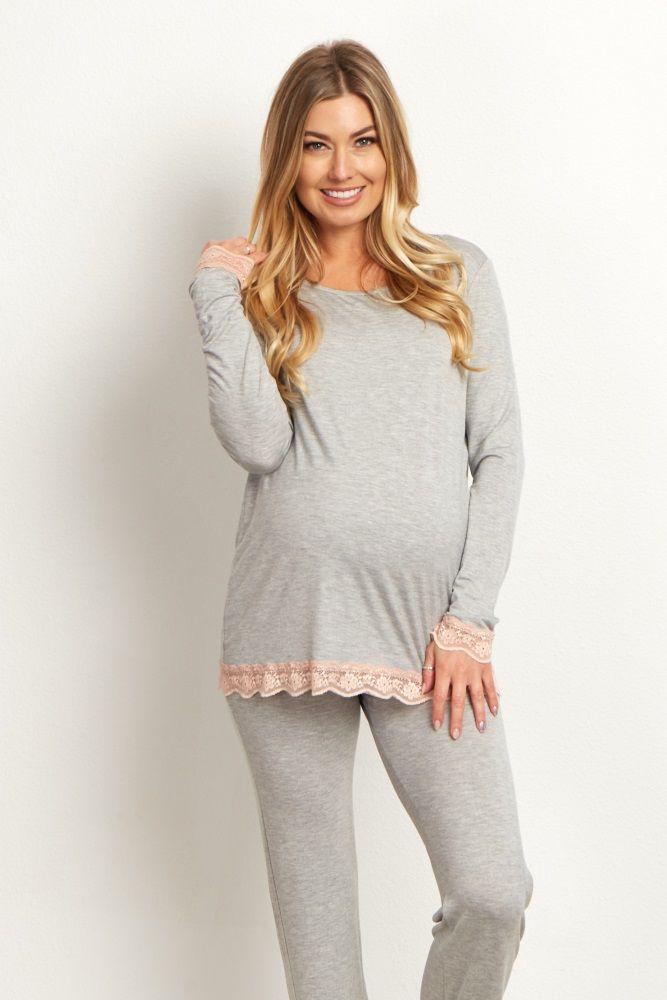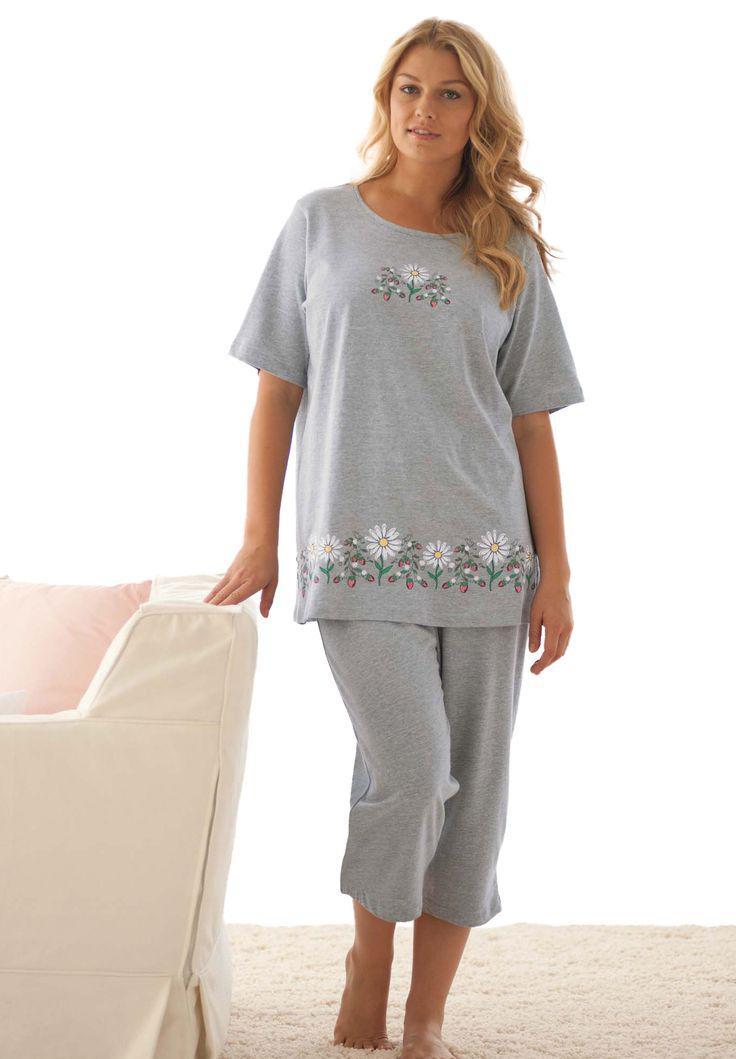The first image is the image on the left, the second image is the image on the right. Evaluate the accuracy of this statement regarding the images: "One woman wears shorts while the other wears pants.". Is it true? Answer yes or no. No. The first image is the image on the left, the second image is the image on the right. For the images displayed, is the sentence "Of two pajama sets, one is pink with long sleeves and pants, while the other is a matching set of top with short pants." factually correct? Answer yes or no. No. 